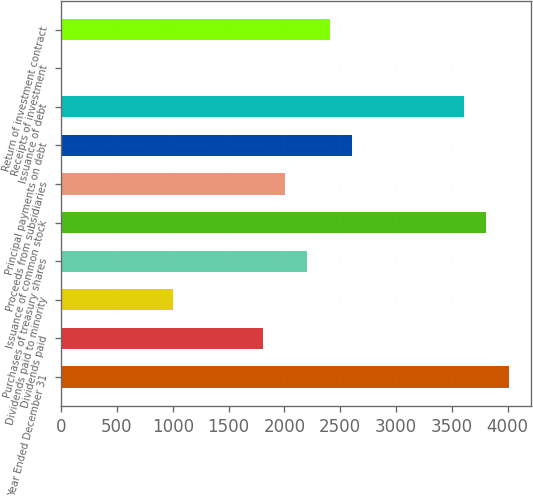<chart> <loc_0><loc_0><loc_500><loc_500><bar_chart><fcel>Year Ended December 31<fcel>Dividends paid<fcel>Dividends paid to minority<fcel>Purchases of treasury shares<fcel>Issuance of common stock<fcel>Proceeds from subsidiaries<fcel>Principal payments on debt<fcel>Issuance of debt<fcel>Receipts of investment<fcel>Return of investment contract<nl><fcel>4008<fcel>1805.8<fcel>1005<fcel>2206.2<fcel>3807.8<fcel>2006<fcel>2606.6<fcel>3607.6<fcel>4<fcel>2406.4<nl></chart> 